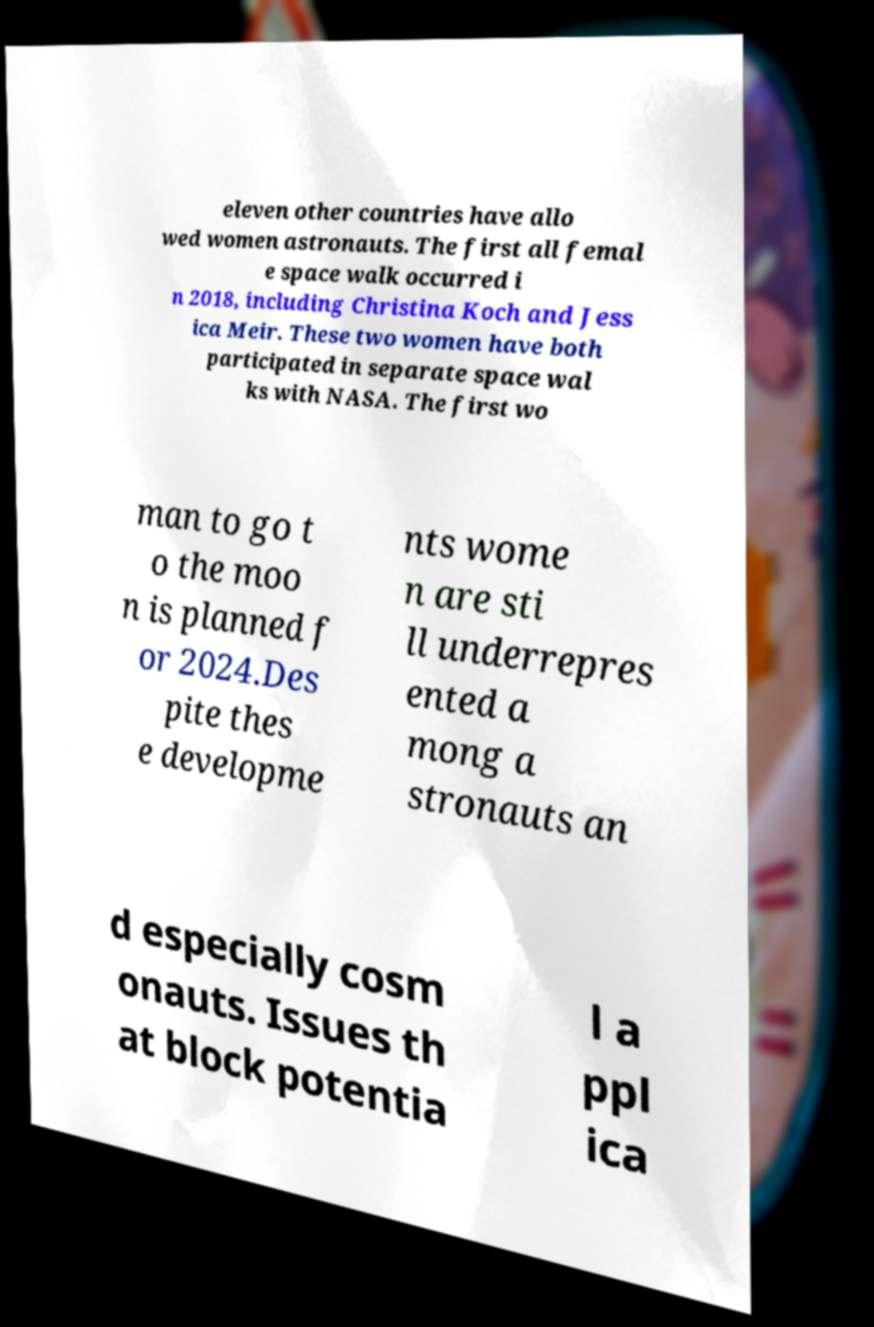Please identify and transcribe the text found in this image. eleven other countries have allo wed women astronauts. The first all femal e space walk occurred i n 2018, including Christina Koch and Jess ica Meir. These two women have both participated in separate space wal ks with NASA. The first wo man to go t o the moo n is planned f or 2024.Des pite thes e developme nts wome n are sti ll underrepres ented a mong a stronauts an d especially cosm onauts. Issues th at block potentia l a ppl ica 